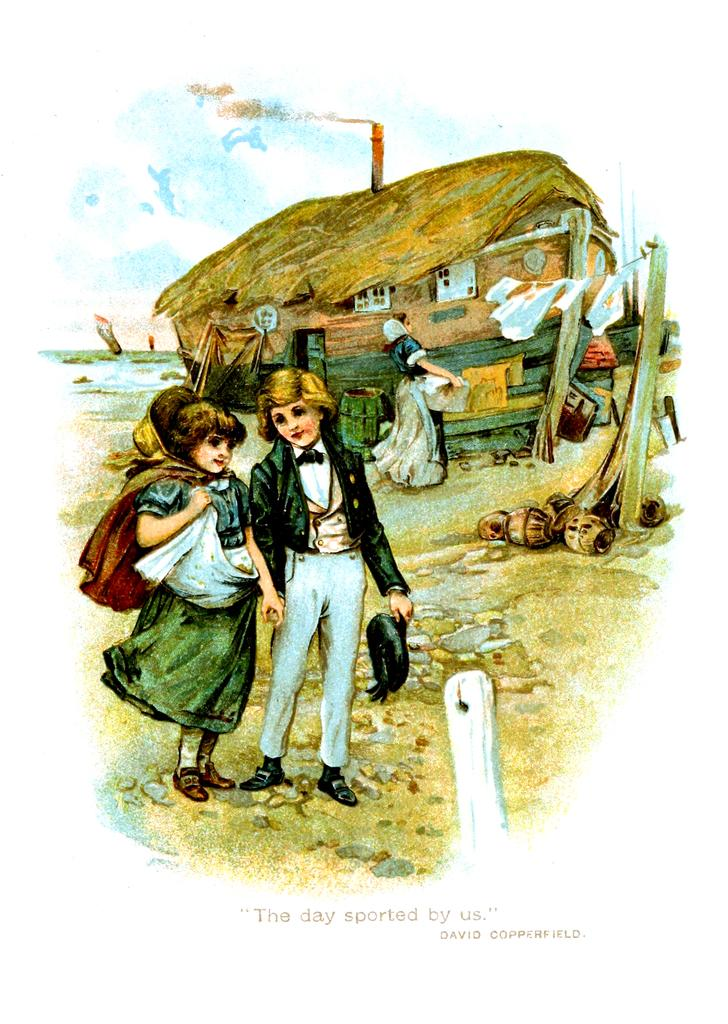What type of image is shown in the picture? The image appears to be a poster. What is depicted on the poster? There is a depiction of people and a house boat on the poster. What can be seen hanging on the poster? Clothes on a rope are shown on the poster. Are there any other objects present on the poster? Yes, there are other objects present on the poster. What is written on the poster? There is text at the bottom side of the poster. Can you see a straw being used by the people on the poster? There is no straw visible in the image; it is a poster depicting people, a house boat, and other objects. Are the people playing volleyball on the poster? There is no indication of a volleyball game or any volleyball-related activity on the poster. 